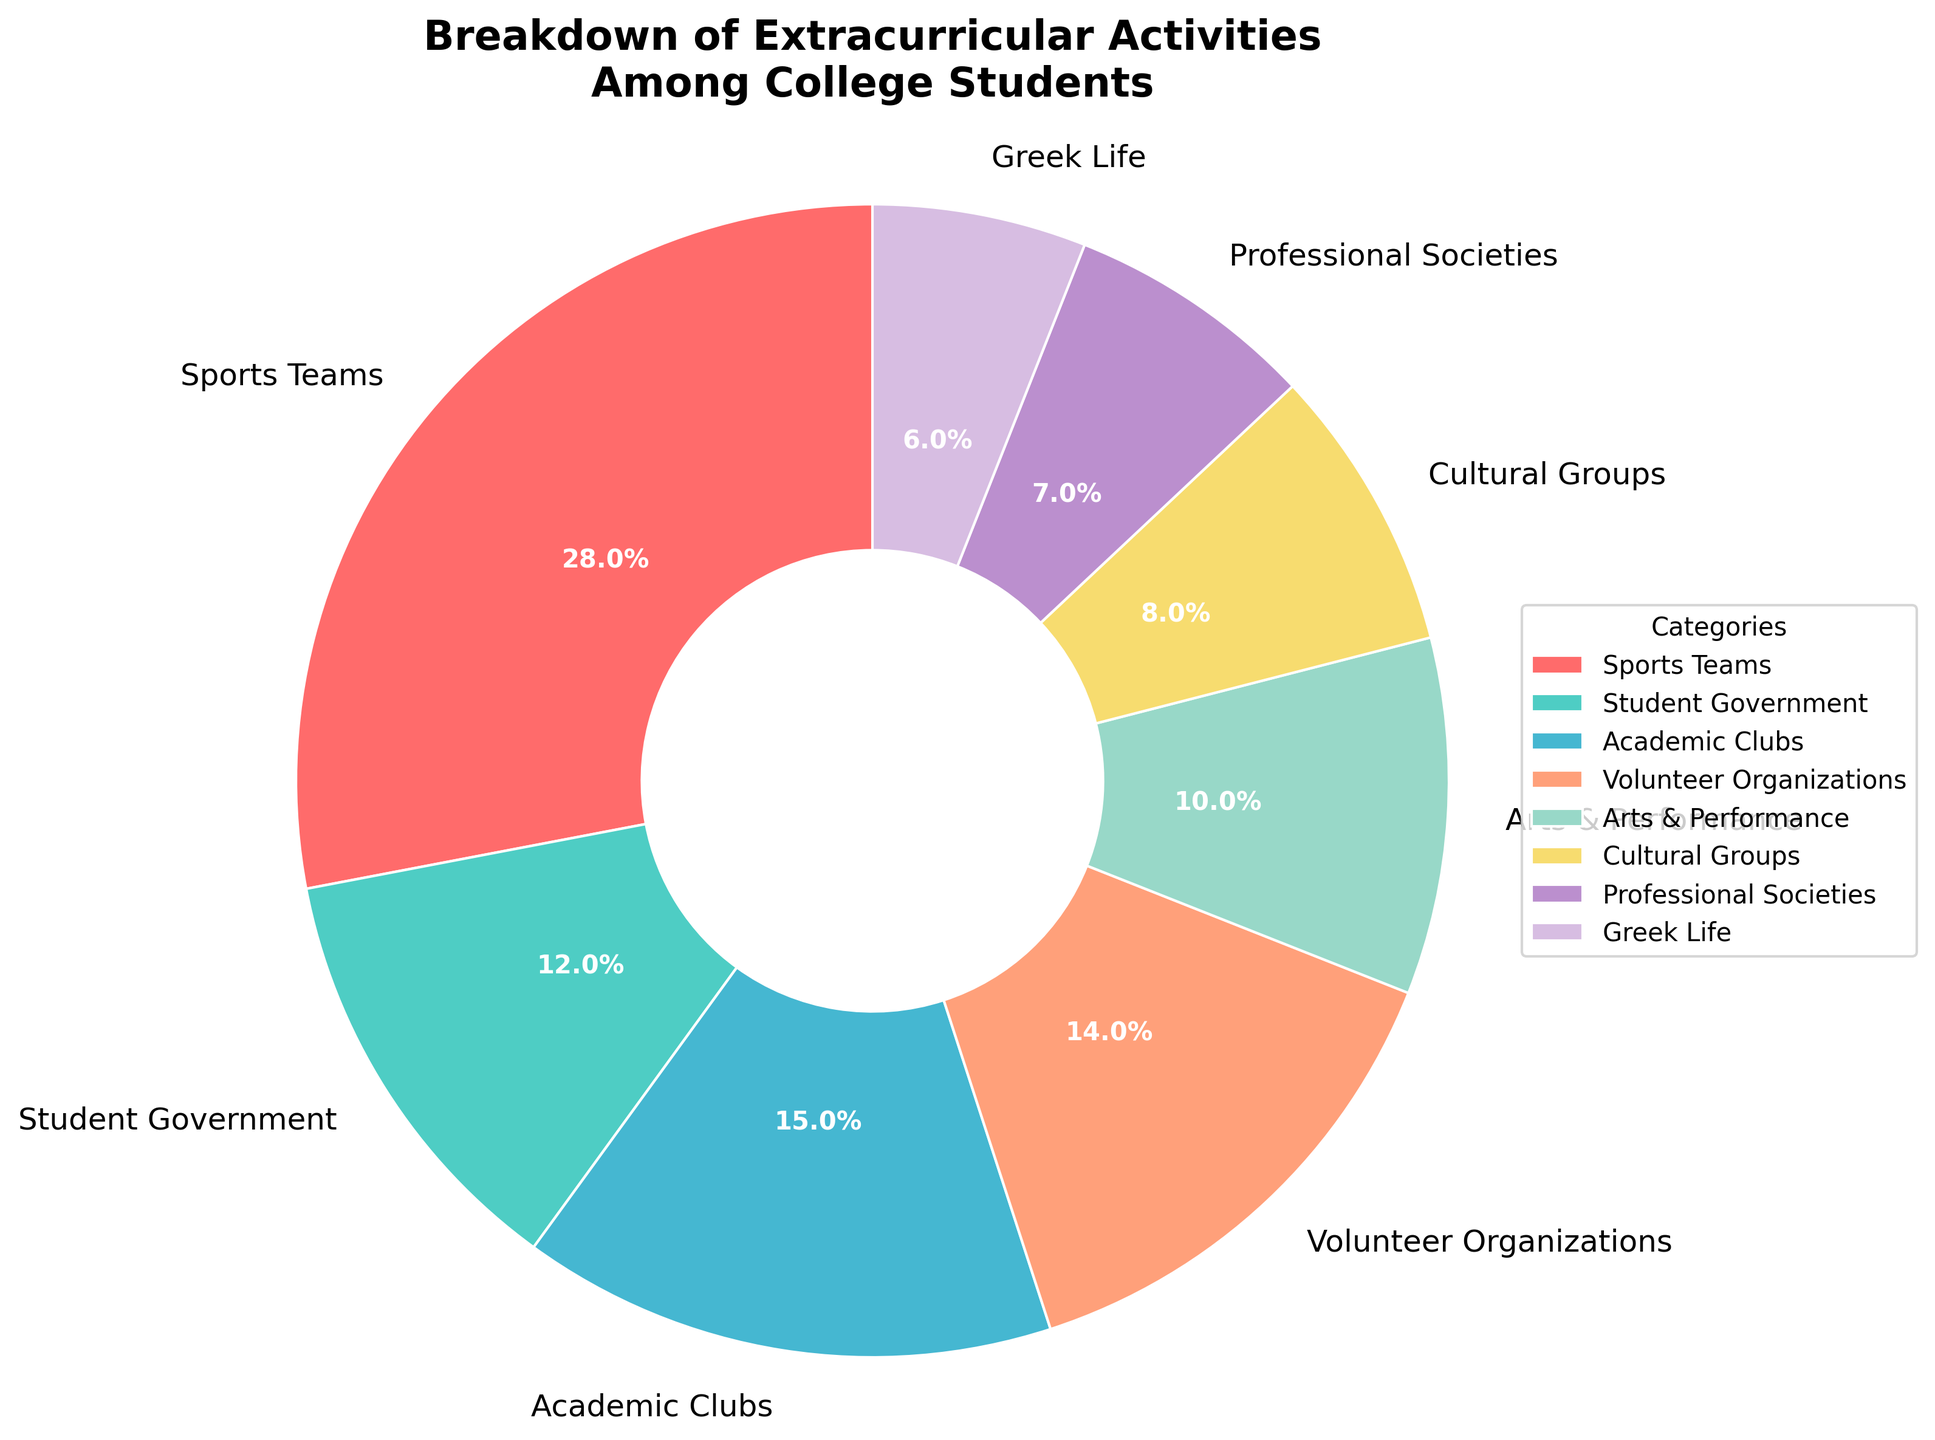What is the second highest category of participation? To find the second highest category of participation, first identify the one with the highest percentage, which is Sports Teams at 28%. The next highest percentage is Academic Clubs at 15%. Therefore, the second highest category of participation is Academic Clubs.
Answer: Academic Clubs Which category has a higher percentage of participation, Cultural Groups or Professional Societies? By comparing the percentages, Cultural Groups have 8% and Professional Societies have 7%. Since 8% is higher than 7%, Cultural Groups have a higher percentage of participation.
Answer: Cultural Groups How much higher is the participation percentage in Volunteer Organizations compared to Greek Life? Volunteer Organizations have a participation percentage of 14%, and Greek Life has 6%. The difference is calculated as 14% - 6% = 8%.
Answer: 8% Which category represents the smallest slice of the pie chart? The smallest slice of the pie chart corresponds to the category with the lowest percentage, which is Greek Life at 6%.
Answer: Greek Life What is the combined participation percentage of Student Government and Academic Clubs? The participation percentages for Student Government and Academic Clubs are 12% and 15% respectively. Adding these together gives 12% + 15% = 27%.
Answer: 27% If you combine the participation percentages of Arts & Performance and Greek Life, how does it compare to that of Sports Teams? Arts & Performance has a 10% participation and Greek Life has 6%. Combined, they total 16%. Comparing this to Sports Teams' 28%, 16% is less than 28%.
Answer: 16% is less Identify the category with a turquoise (greenish-blue) color in the pie chart. The vibrant colors used in the pie chart include turquoise (greenish-blue), which represents the Student Government category with a 12% participation rate.
Answer: Student Government What percentage of participation is attributed to Professional Societies and Cultural Groups combined? Professional Societies account for 7% and Cultural Groups account for 8%. Combined, the participation percentage is 7% + 8% = 15%.
Answer: 15% Which categories form more than one-third of the entire pie chart when combined? Adding the percentages of the categories: Sports Teams (28%), Academic Clubs (15%), and Student Government (12%), we get 28% + 15% + 12% = 55%. Since 55% is more than 33.33% (one-third), these three categories combined form more than one-third of the pie chart.
Answer: Sports Teams, Academic Clubs, Student Government Are there any categories with equal participation percentages? By examining the data, there are no two categories that share the same participation percentage. Each category has a unique percentage.
Answer: No 